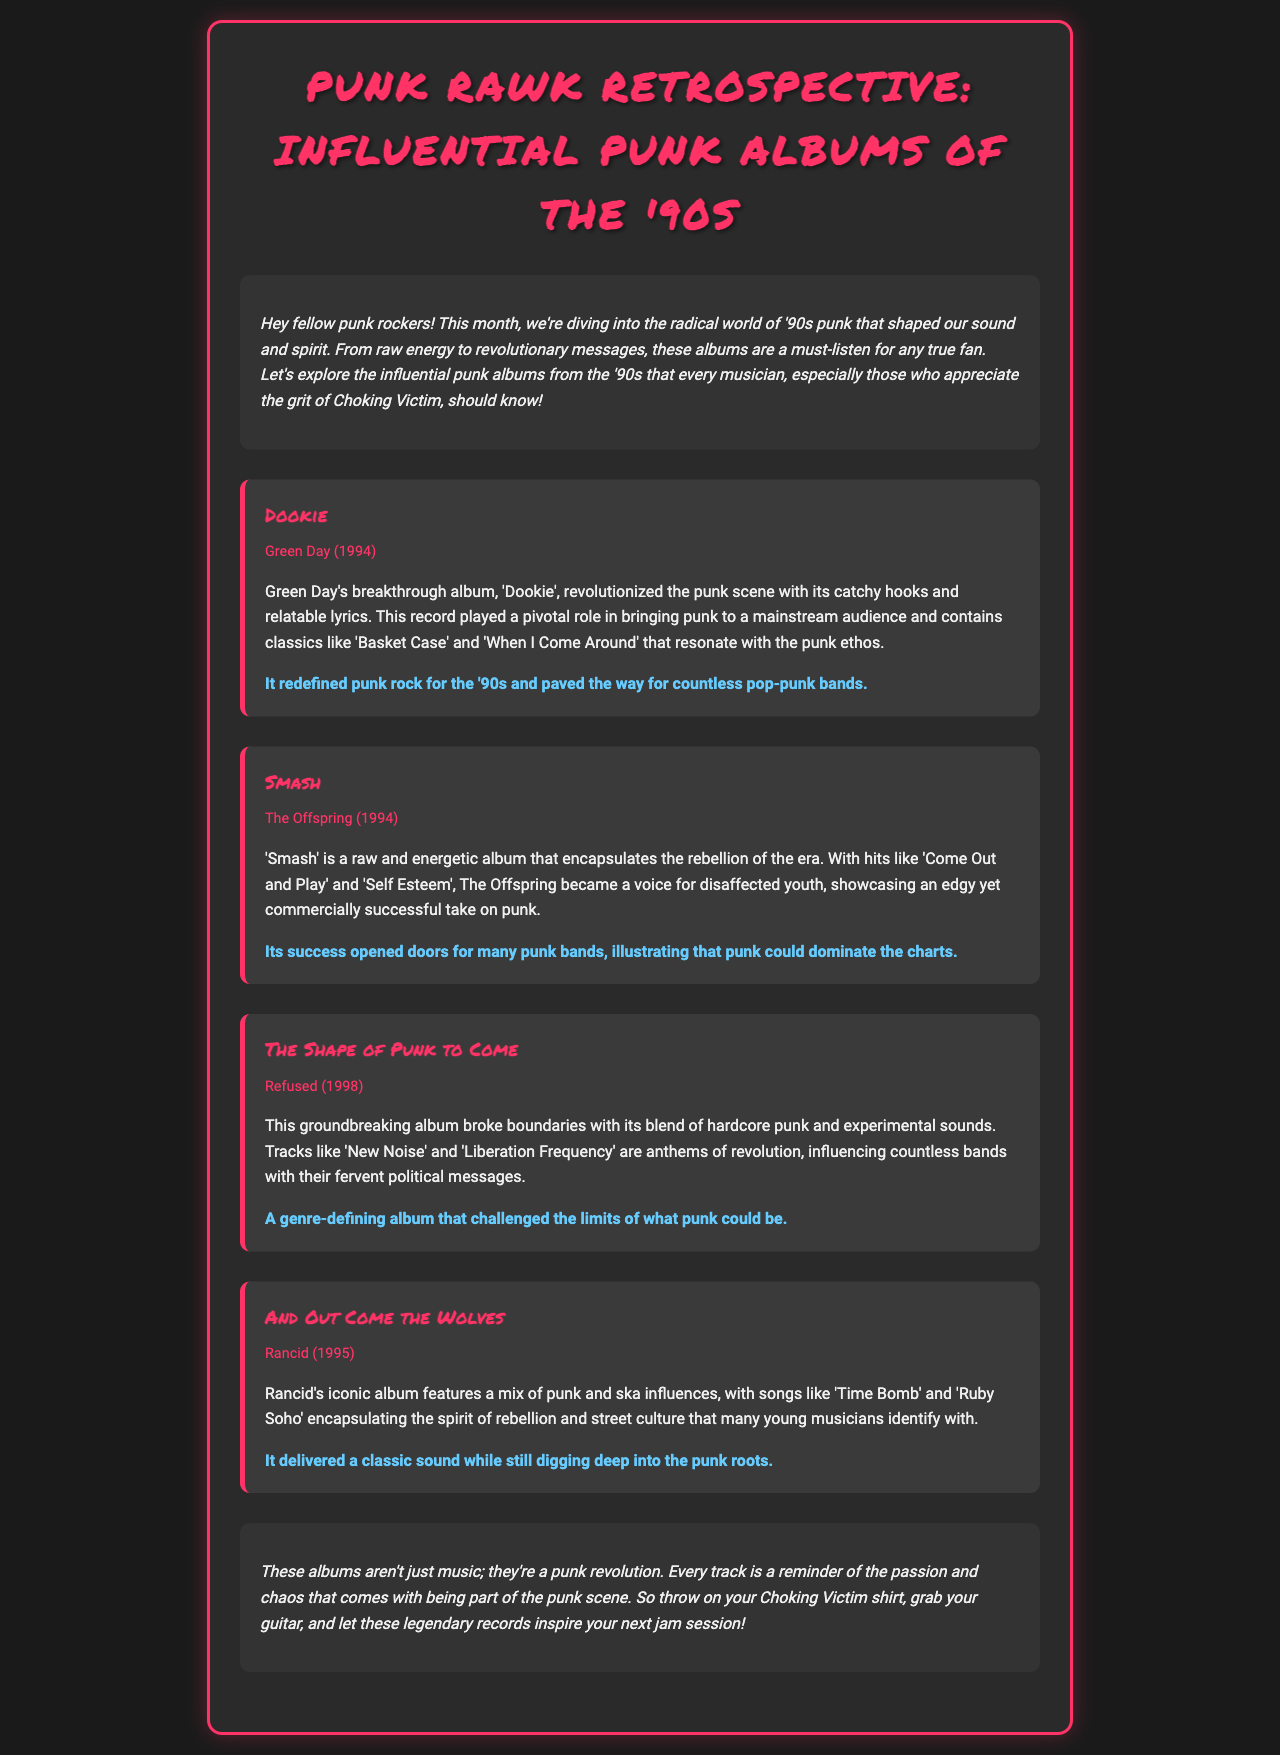What is the title of the newsletter? The title of the newsletter is presented at the top of the document and is "Punk Rawk Retrospective: Influential Punk Albums of the '90s."
Answer: Punk Rawk Retrospective: Influential Punk Albums of the '90s Who is the artist of the album "Dookie"? The artist associated with the album "Dookie" is mentioned in the details.
Answer: Green Day What year was "Smash" released? The year of release for the album "Smash" is specified in the document.
Answer: 1994 Which album features the track "New Noise"? The album that includes the track "New Noise" is noted in the section about Refused.
Answer: The Shape of Punk to Come What genre does "And Out Come the Wolves" blend with punk? The genre that is mentioned as being blended with punk in the album "And Out Come the Wolves" is included in the description.
Answer: Ska How did the album "Dookie" influence the punk scene? The impact of "Dookie" on the punk scene is described based on its role in bringing punk to mainstream audiences.
Answer: It redefined punk rock for the '90s and paved the way for countless pop-punk bands What is a recurring theme in the influential albums mentioned? The document suggests a common theme among these albums, which relates to their emotional or thematic content.
Answer: Rebellion Which album is referred to as "a genre-defining album"? The album described as "a genre-defining album" is identified within the text discussing its impact.
Answer: The Shape of Punk to Come 